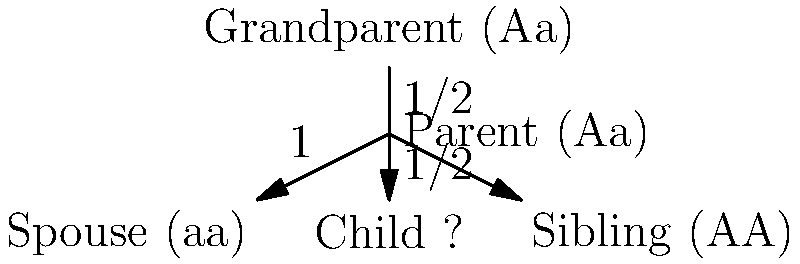Given the family tree diagram showing the inheritance of a specific trait (A) through three generations, what is the probability that the child will inherit the dominant allele (A) and express the trait? Assume that the trait follows simple Mendelian inheritance patterns. To solve this problem, we need to follow these steps:

1. Identify the genotypes:
   - Grandparent: Aa (heterozygous)
   - Parent: Aa (heterozygous)
   - Spouse: aa (homozygous recessive)
   - Sibling: AA (homozygous dominant)

2. Focus on the Parent-Child relationship:
   - The parent (Aa) can pass either A or a to the child.
   - The probability of passing A is 1/2, and the probability of passing a is 1/2.

3. Consider the Spouse's contribution:
   - The spouse (aa) can only pass the recessive allele a.

4. Calculate the probability of the child inheriting A:
   - The child needs to receive the A allele from the parent to express the trait.
   - This probability is 1/2, as shown in the diagram.

5. The spouse's contribution doesn't affect the probability of inheriting A:
   - Even though the spouse contributes an a allele, it doesn't change the chance of getting A from the parent.

Therefore, the probability of the child inheriting the dominant allele (A) and expressing the trait is 1/2 or 0.5 or 50%.
Answer: $\frac{1}{2}$ or 0.5 or 50% 